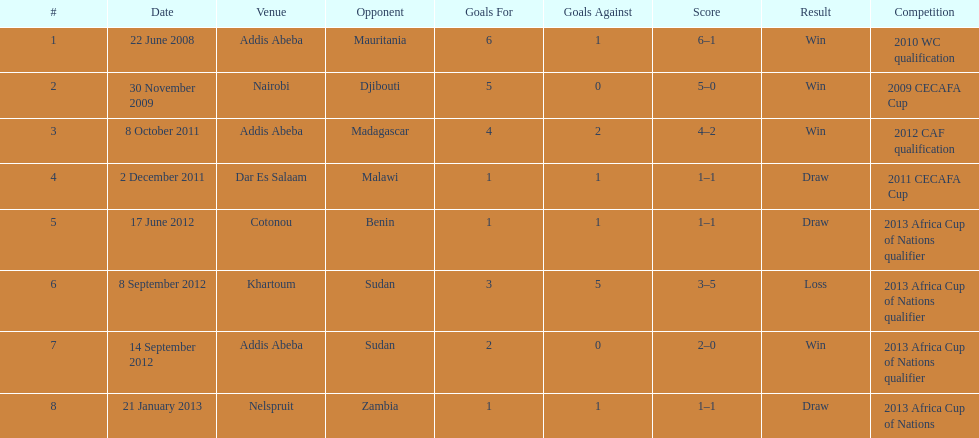What date gives was their only loss? 8 September 2012. 